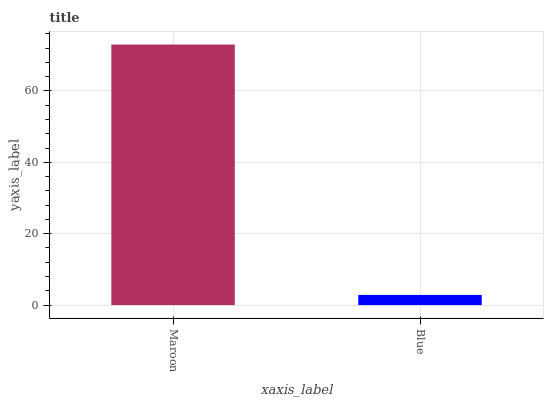Is Blue the minimum?
Answer yes or no. Yes. Is Maroon the maximum?
Answer yes or no. Yes. Is Blue the maximum?
Answer yes or no. No. Is Maroon greater than Blue?
Answer yes or no. Yes. Is Blue less than Maroon?
Answer yes or no. Yes. Is Blue greater than Maroon?
Answer yes or no. No. Is Maroon less than Blue?
Answer yes or no. No. Is Maroon the high median?
Answer yes or no. Yes. Is Blue the low median?
Answer yes or no. Yes. Is Blue the high median?
Answer yes or no. No. Is Maroon the low median?
Answer yes or no. No. 